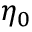Convert formula to latex. <formula><loc_0><loc_0><loc_500><loc_500>\eta _ { 0 }</formula> 